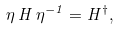<formula> <loc_0><loc_0><loc_500><loc_500>\eta \, H \, \eta ^ { - 1 } = H ^ { \dagger } ,</formula> 